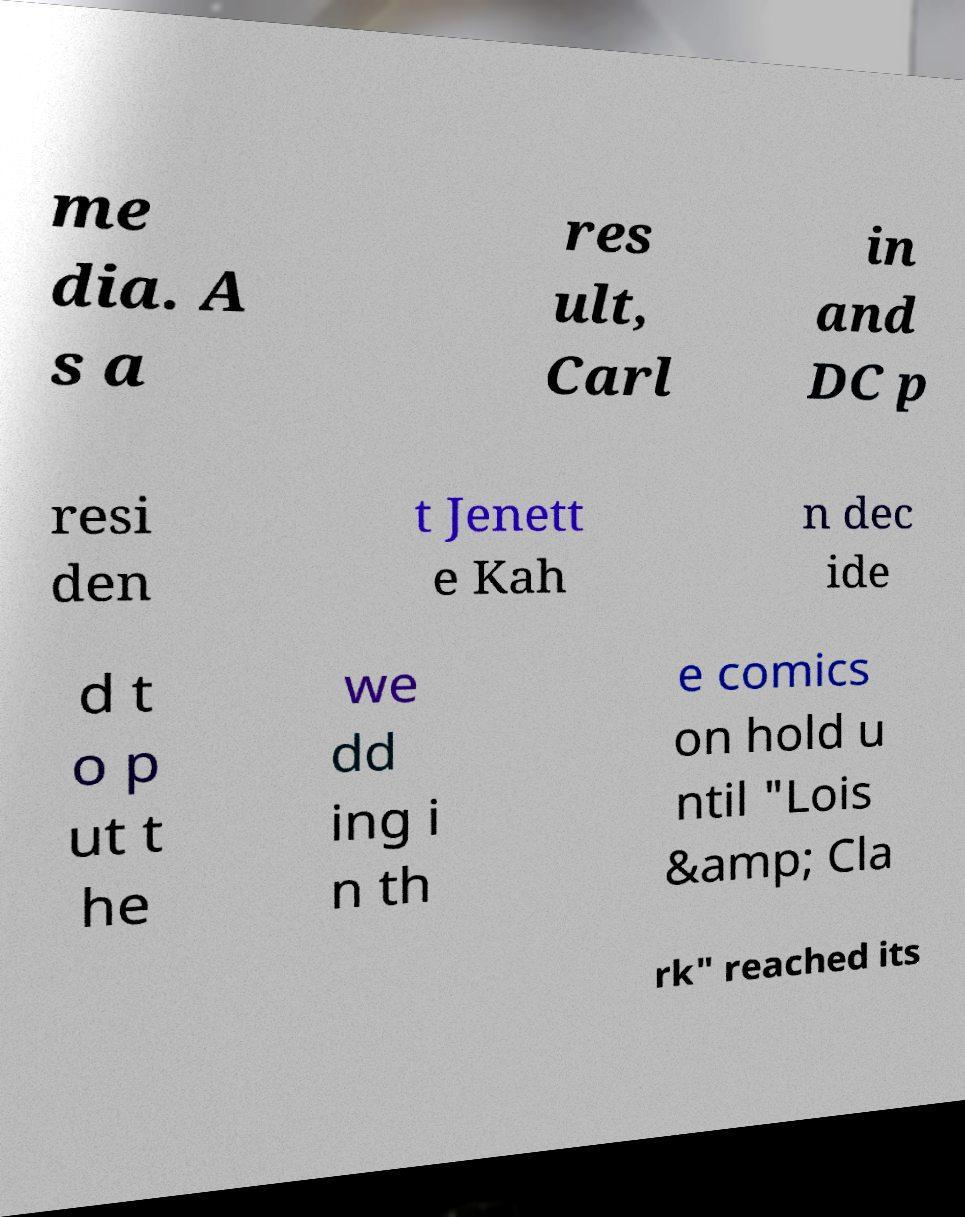Could you extract and type out the text from this image? me dia. A s a res ult, Carl in and DC p resi den t Jenett e Kah n dec ide d t o p ut t he we dd ing i n th e comics on hold u ntil "Lois &amp; Cla rk" reached its 